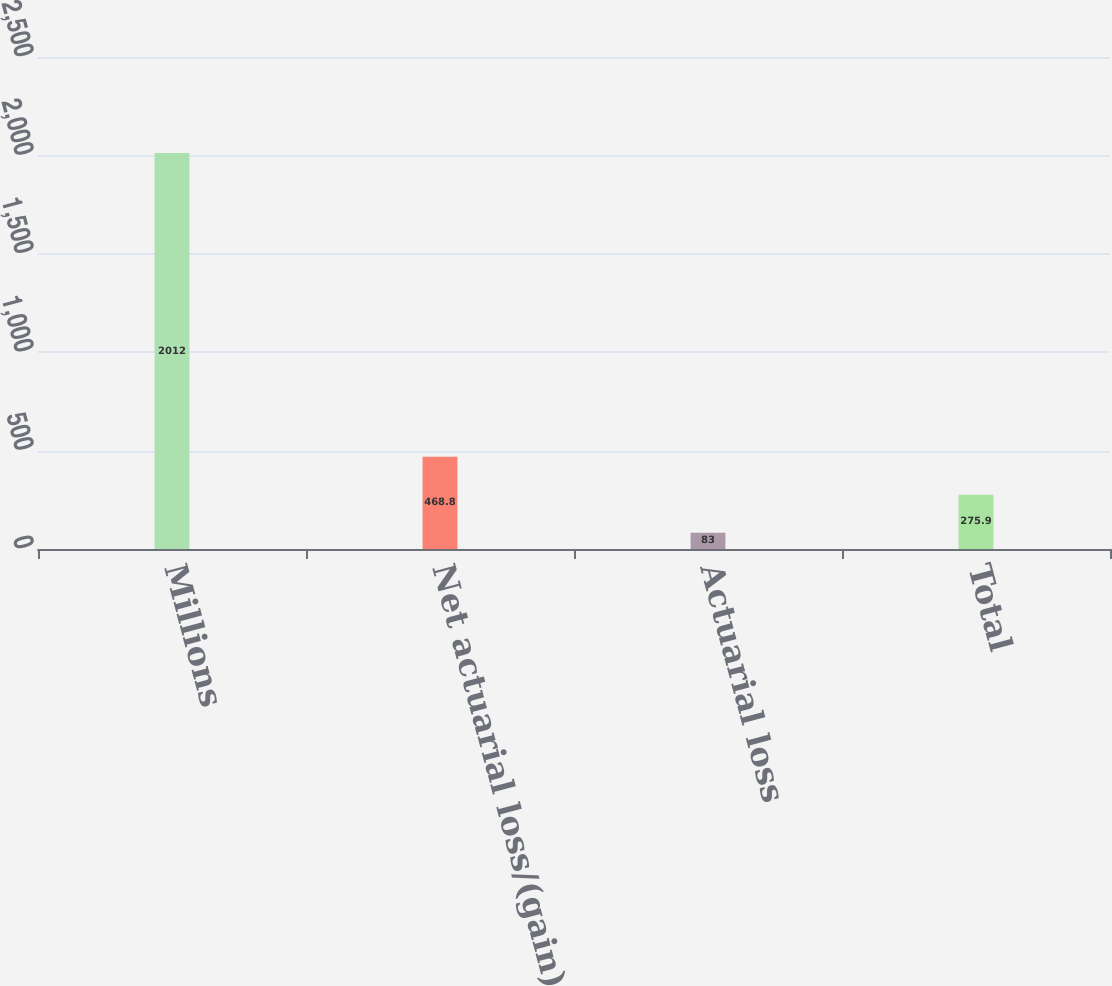Convert chart. <chart><loc_0><loc_0><loc_500><loc_500><bar_chart><fcel>Millions<fcel>Net actuarial loss/(gain)<fcel>Actuarial loss<fcel>Total<nl><fcel>2012<fcel>468.8<fcel>83<fcel>275.9<nl></chart> 